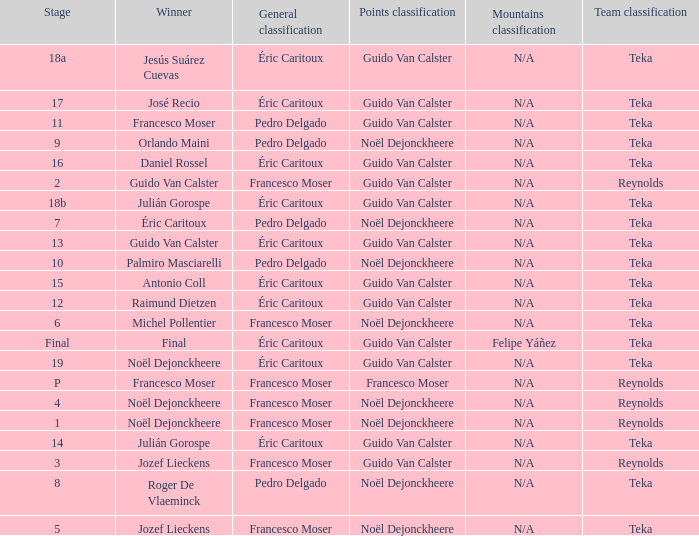Name the points classification of stage 16 Guido Van Calster. Give me the full table as a dictionary. {'header': ['Stage', 'Winner', 'General classification', 'Points classification', 'Mountains classification', 'Team classification'], 'rows': [['18a', 'Jesús Suárez Cuevas', 'Éric Caritoux', 'Guido Van Calster', 'N/A', 'Teka'], ['17', 'José Recio', 'Éric Caritoux', 'Guido Van Calster', 'N/A', 'Teka'], ['11', 'Francesco Moser', 'Pedro Delgado', 'Guido Van Calster', 'N/A', 'Teka'], ['9', 'Orlando Maini', 'Pedro Delgado', 'Noël Dejonckheere', 'N/A', 'Teka'], ['16', 'Daniel Rossel', 'Éric Caritoux', 'Guido Van Calster', 'N/A', 'Teka'], ['2', 'Guido Van Calster', 'Francesco Moser', 'Guido Van Calster', 'N/A', 'Reynolds'], ['18b', 'Julián Gorospe', 'Éric Caritoux', 'Guido Van Calster', 'N/A', 'Teka'], ['7', 'Éric Caritoux', 'Pedro Delgado', 'Noël Dejonckheere', 'N/A', 'Teka'], ['13', 'Guido Van Calster', 'Éric Caritoux', 'Guido Van Calster', 'N/A', 'Teka'], ['10', 'Palmiro Masciarelli', 'Pedro Delgado', 'Noël Dejonckheere', 'N/A', 'Teka'], ['15', 'Antonio Coll', 'Éric Caritoux', 'Guido Van Calster', 'N/A', 'Teka'], ['12', 'Raimund Dietzen', 'Éric Caritoux', 'Guido Van Calster', 'N/A', 'Teka'], ['6', 'Michel Pollentier', 'Francesco Moser', 'Noël Dejonckheere', 'N/A', 'Teka'], ['Final', 'Final', 'Éric Caritoux', 'Guido Van Calster', 'Felipe Yáñez', 'Teka'], ['19', 'Noël Dejonckheere', 'Éric Caritoux', 'Guido Van Calster', 'N/A', 'Teka'], ['P', 'Francesco Moser', 'Francesco Moser', 'Francesco Moser', 'N/A', 'Reynolds'], ['4', 'Noël Dejonckheere', 'Francesco Moser', 'Noël Dejonckheere', 'N/A', 'Reynolds'], ['1', 'Noël Dejonckheere', 'Francesco Moser', 'Noël Dejonckheere', 'N/A', 'Reynolds'], ['14', 'Julián Gorospe', 'Éric Caritoux', 'Guido Van Calster', 'N/A', 'Teka'], ['3', 'Jozef Lieckens', 'Francesco Moser', 'Guido Van Calster', 'N/A', 'Reynolds'], ['8', 'Roger De Vlaeminck', 'Pedro Delgado', 'Noël Dejonckheere', 'N/A', 'Teka'], ['5', 'Jozef Lieckens', 'Francesco Moser', 'Noël Dejonckheere', 'N/A', 'Teka']]} 